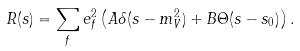Convert formula to latex. <formula><loc_0><loc_0><loc_500><loc_500>R ( s ) = \sum _ { f } e _ { f } ^ { 2 } \left ( A \delta ( s - m _ { V } ^ { 2 } ) + B \Theta ( s - s _ { 0 } ) \right ) .</formula> 